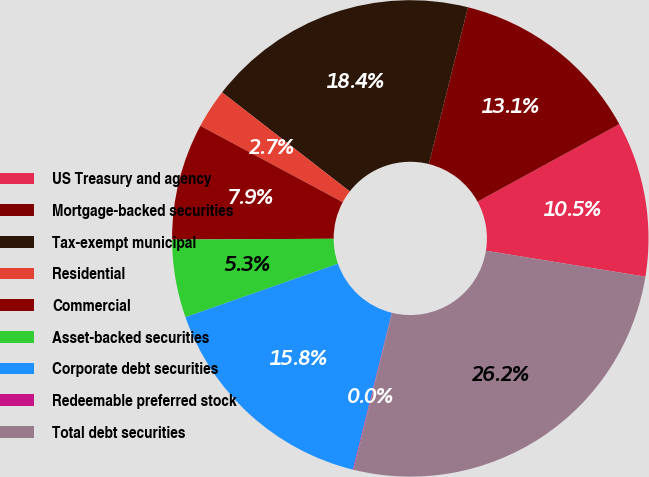Convert chart. <chart><loc_0><loc_0><loc_500><loc_500><pie_chart><fcel>US Treasury and agency<fcel>Mortgage-backed securities<fcel>Tax-exempt municipal<fcel>Residential<fcel>Commercial<fcel>Asset-backed securities<fcel>Corporate debt securities<fcel>Redeemable preferred stock<fcel>Total debt securities<nl><fcel>10.53%<fcel>13.15%<fcel>18.39%<fcel>2.67%<fcel>7.91%<fcel>5.29%<fcel>15.77%<fcel>0.05%<fcel>26.25%<nl></chart> 